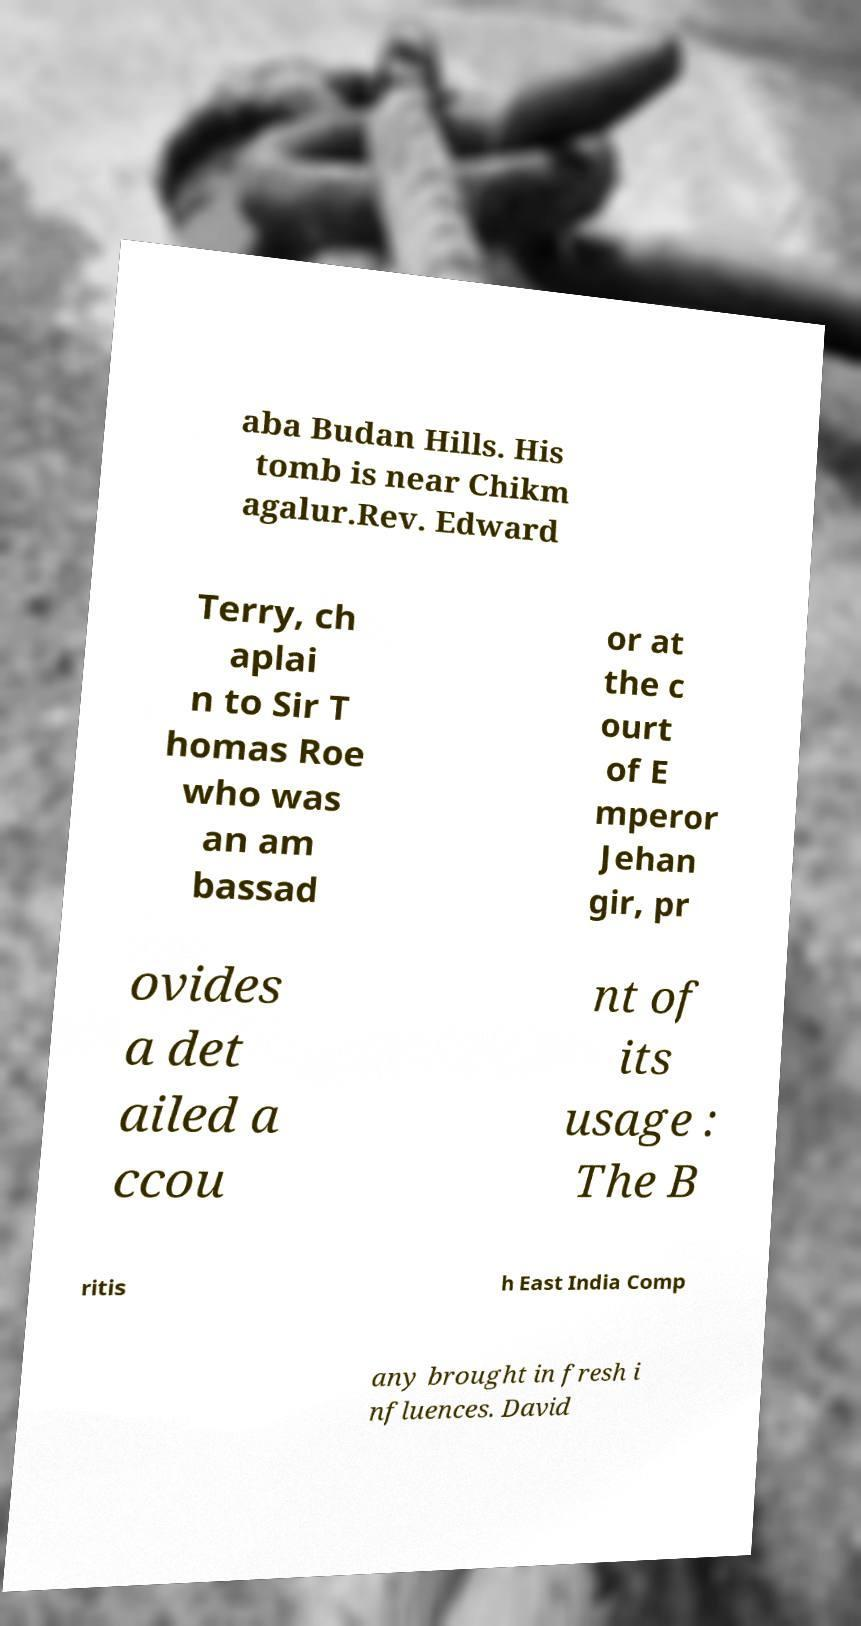Can you read and provide the text displayed in the image?This photo seems to have some interesting text. Can you extract and type it out for me? aba Budan Hills. His tomb is near Chikm agalur.Rev. Edward Terry, ch aplai n to Sir T homas Roe who was an am bassad or at the c ourt of E mperor Jehan gir, pr ovides a det ailed a ccou nt of its usage : The B ritis h East India Comp any brought in fresh i nfluences. David 